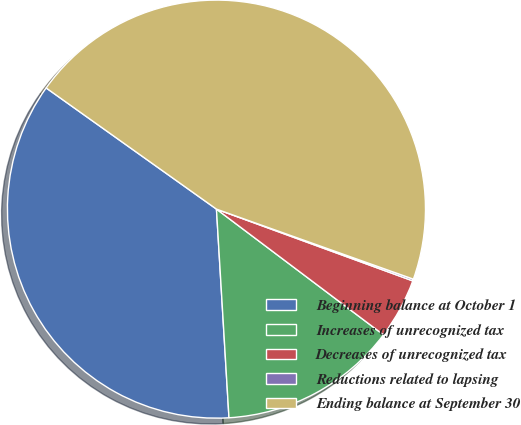Convert chart to OTSL. <chart><loc_0><loc_0><loc_500><loc_500><pie_chart><fcel>Beginning balance at October 1<fcel>Increases of unrecognized tax<fcel>Decreases of unrecognized tax<fcel>Reductions related to lapsing<fcel>Ending balance at September 30<nl><fcel>35.8%<fcel>13.78%<fcel>4.69%<fcel>0.14%<fcel>45.6%<nl></chart> 